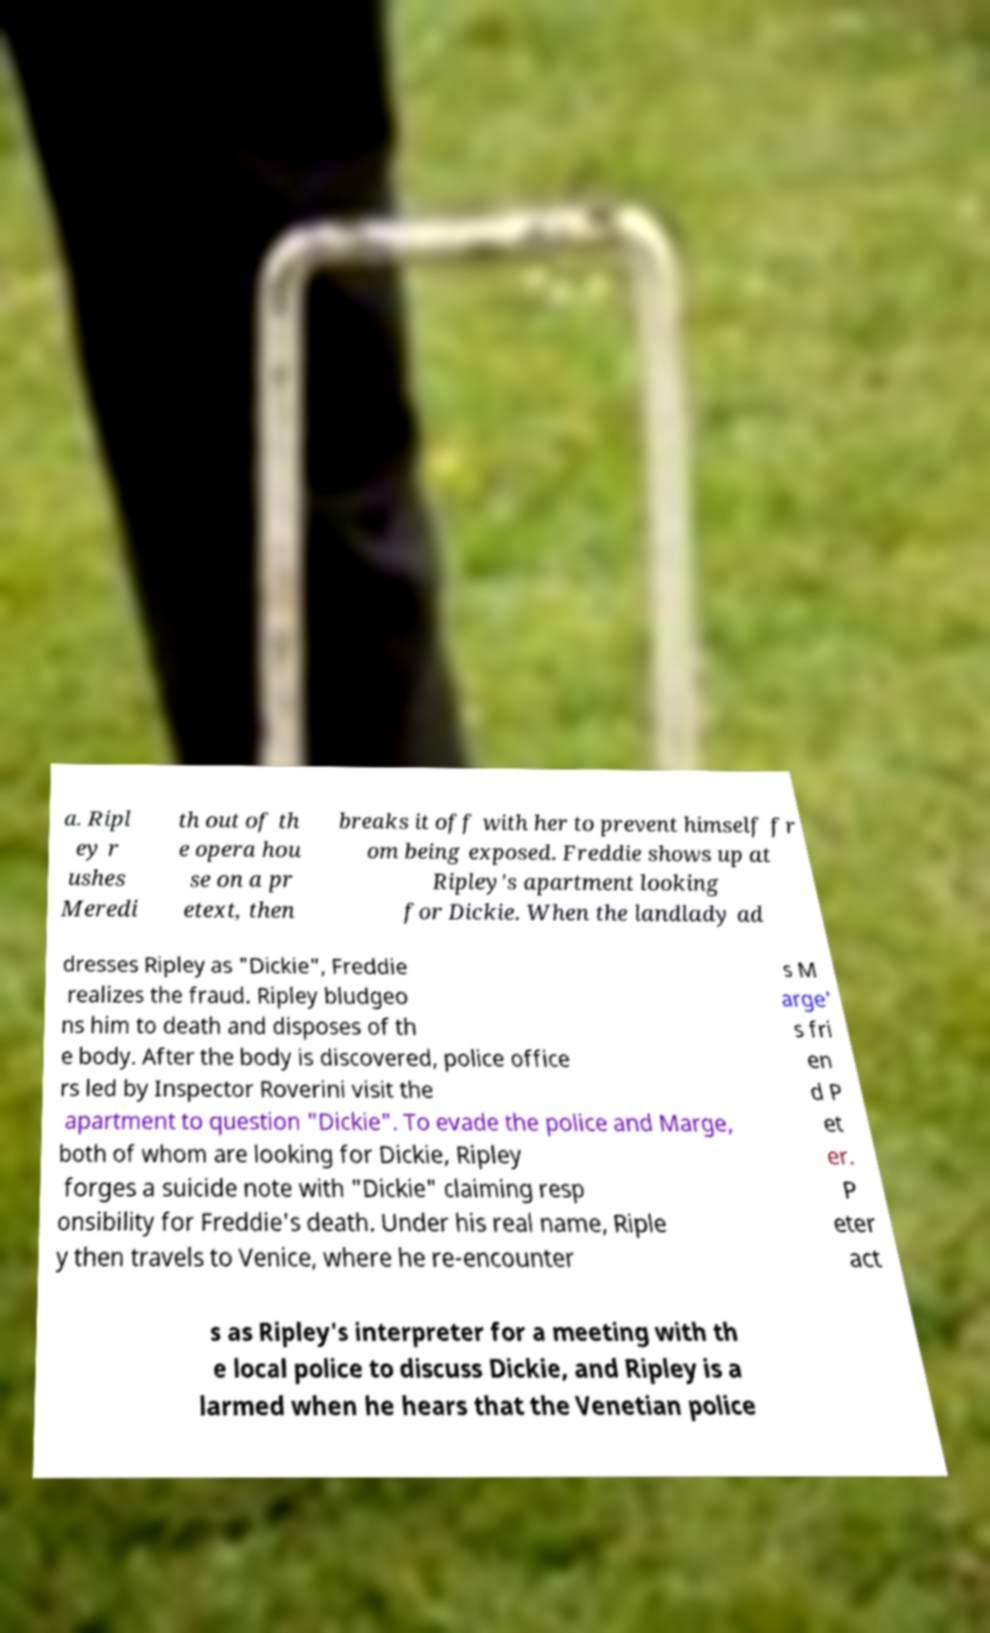Can you read and provide the text displayed in the image?This photo seems to have some interesting text. Can you extract and type it out for me? a. Ripl ey r ushes Meredi th out of th e opera hou se on a pr etext, then breaks it off with her to prevent himself fr om being exposed. Freddie shows up at Ripley's apartment looking for Dickie. When the landlady ad dresses Ripley as "Dickie", Freddie realizes the fraud. Ripley bludgeo ns him to death and disposes of th e body. After the body is discovered, police office rs led by Inspector Roverini visit the apartment to question "Dickie". To evade the police and Marge, both of whom are looking for Dickie, Ripley forges a suicide note with "Dickie" claiming resp onsibility for Freddie's death. Under his real name, Riple y then travels to Venice, where he re-encounter s M arge' s fri en d P et er. P eter act s as Ripley's interpreter for a meeting with th e local police to discuss Dickie, and Ripley is a larmed when he hears that the Venetian police 